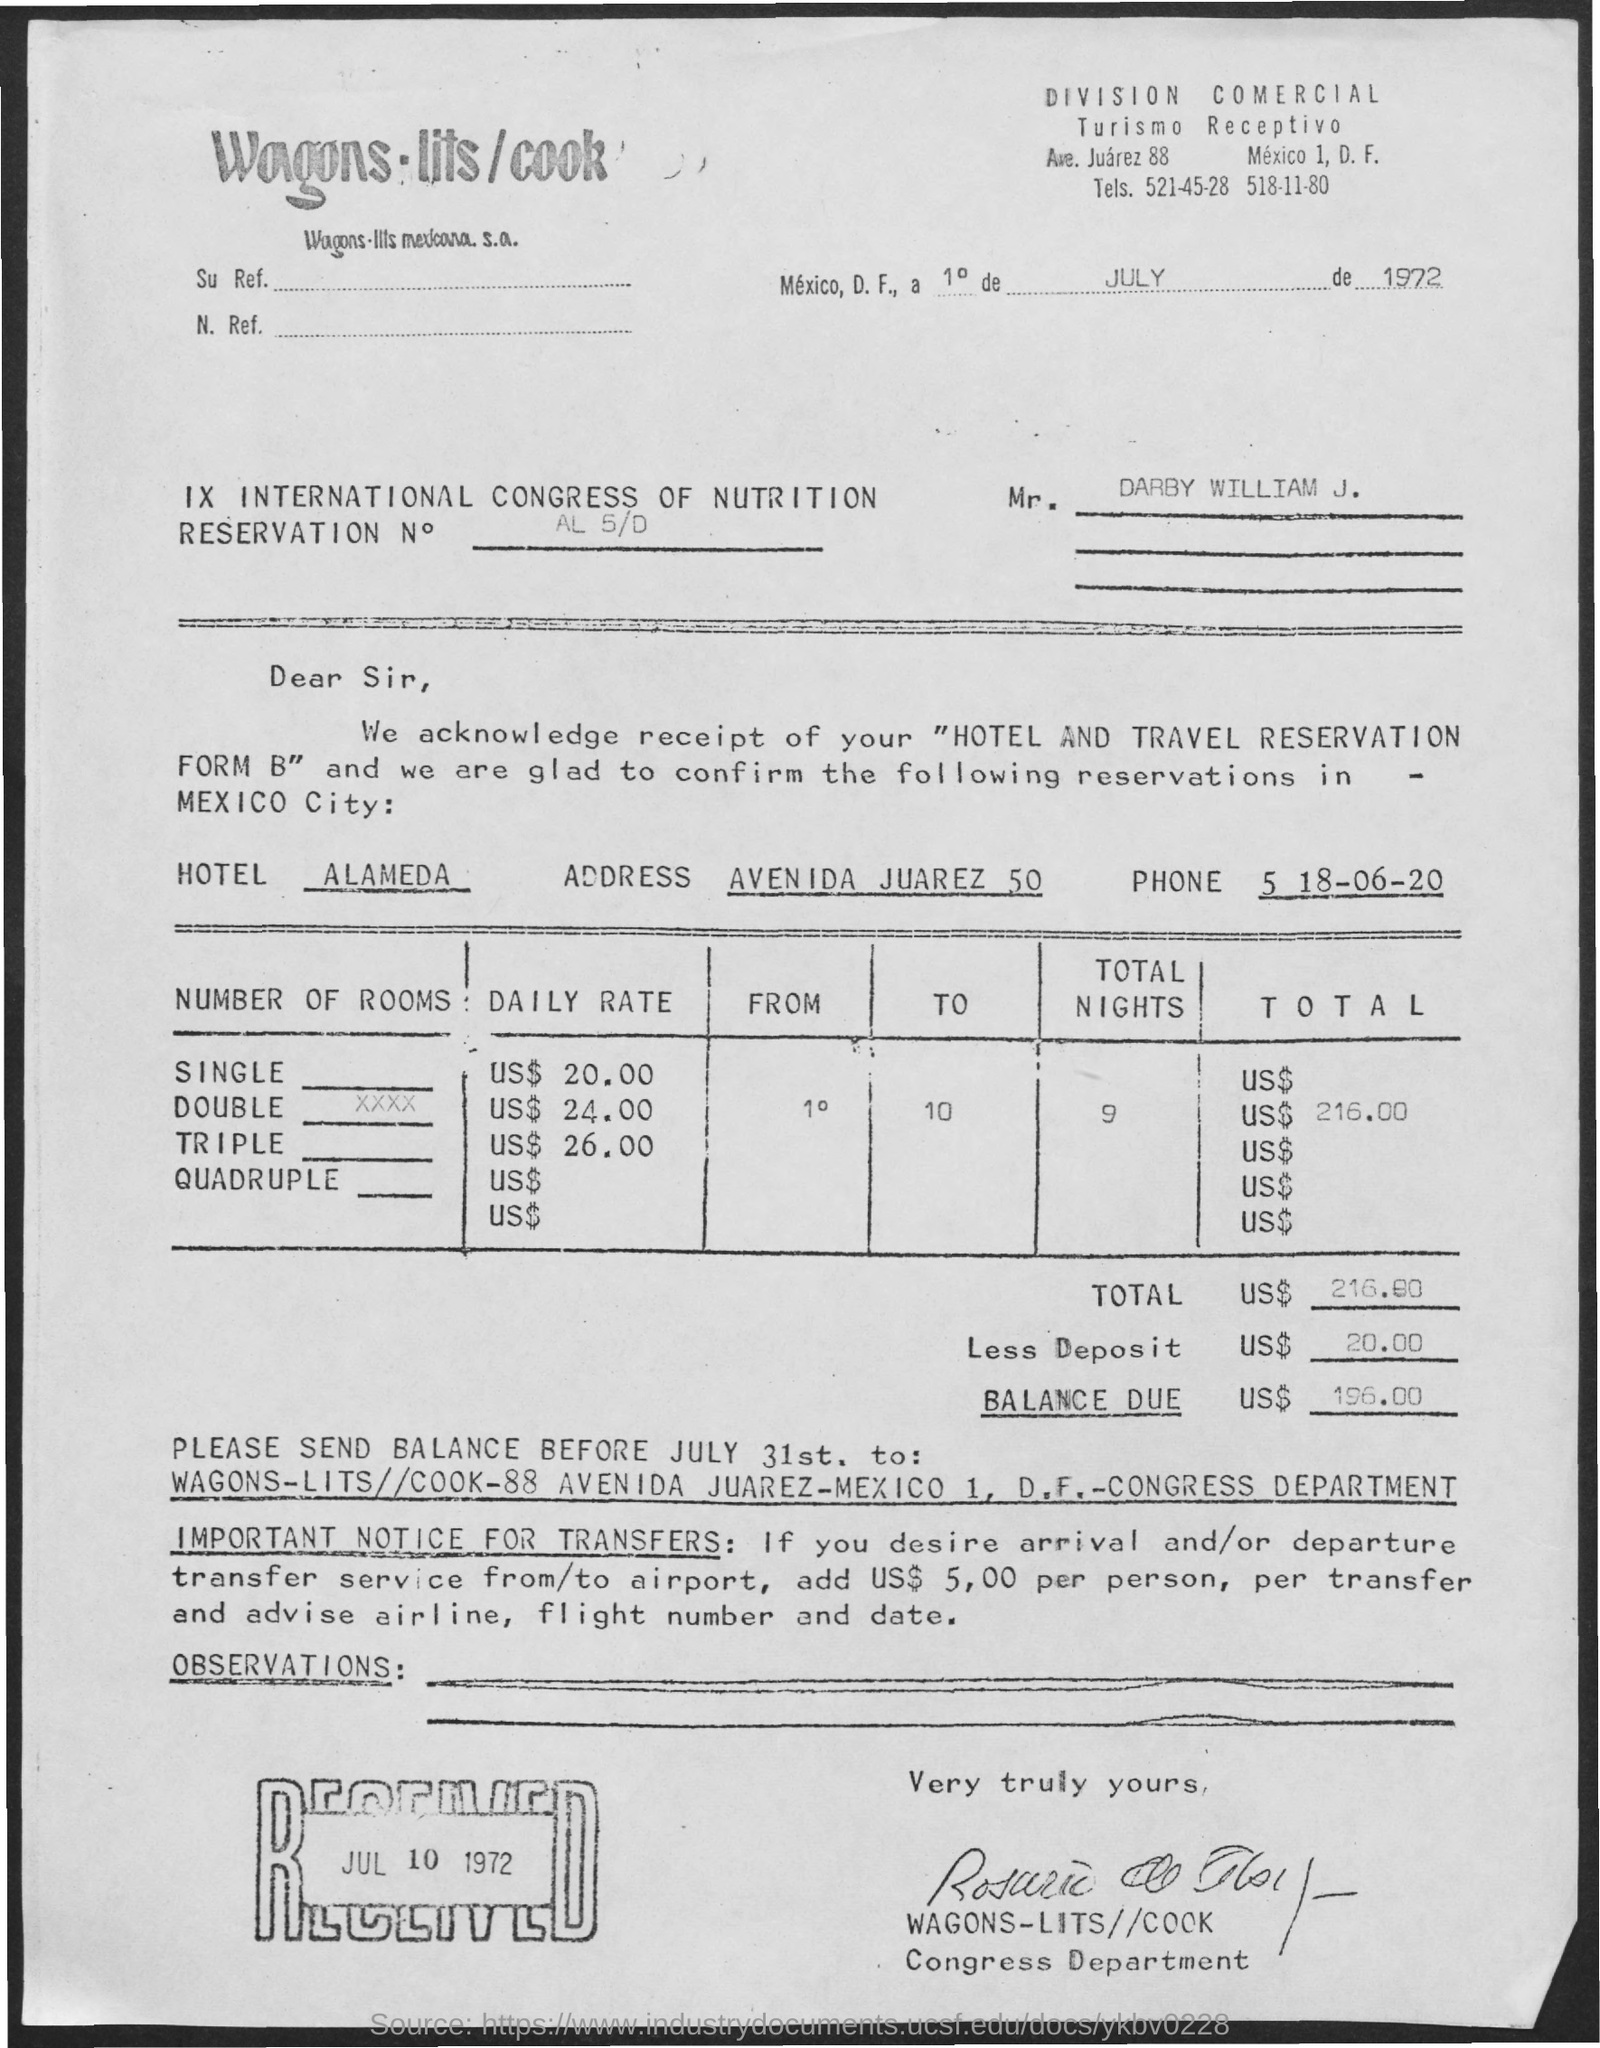What is the name of the hotel?
Keep it short and to the point. Alameda. 